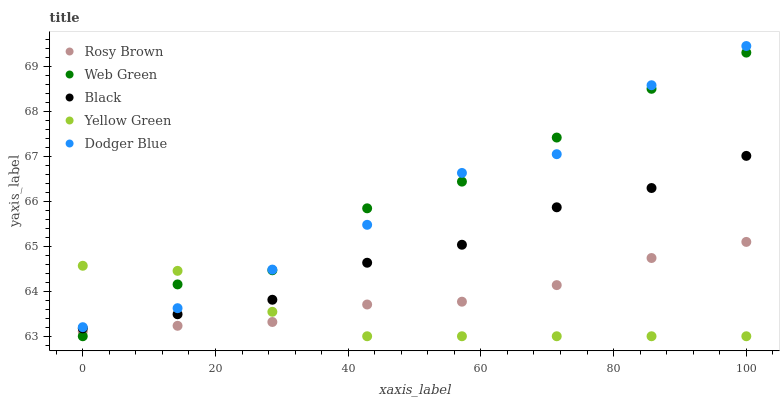Does Yellow Green have the minimum area under the curve?
Answer yes or no. Yes. Does Web Green have the maximum area under the curve?
Answer yes or no. Yes. Does Rosy Brown have the minimum area under the curve?
Answer yes or no. No. Does Rosy Brown have the maximum area under the curve?
Answer yes or no. No. Is Rosy Brown the smoothest?
Answer yes or no. Yes. Is Web Green the roughest?
Answer yes or no. Yes. Is Black the smoothest?
Answer yes or no. No. Is Black the roughest?
Answer yes or no. No. Does Yellow Green have the lowest value?
Answer yes or no. Yes. Does Rosy Brown have the lowest value?
Answer yes or no. No. Does Dodger Blue have the highest value?
Answer yes or no. Yes. Does Rosy Brown have the highest value?
Answer yes or no. No. Is Rosy Brown less than Dodger Blue?
Answer yes or no. Yes. Is Dodger Blue greater than Rosy Brown?
Answer yes or no. Yes. Does Dodger Blue intersect Web Green?
Answer yes or no. Yes. Is Dodger Blue less than Web Green?
Answer yes or no. No. Is Dodger Blue greater than Web Green?
Answer yes or no. No. Does Rosy Brown intersect Dodger Blue?
Answer yes or no. No. 